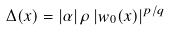Convert formula to latex. <formula><loc_0><loc_0><loc_500><loc_500>\Delta ( x ) = | \alpha | \, \rho \, | w _ { 0 } ( x ) | ^ { p / q }</formula> 